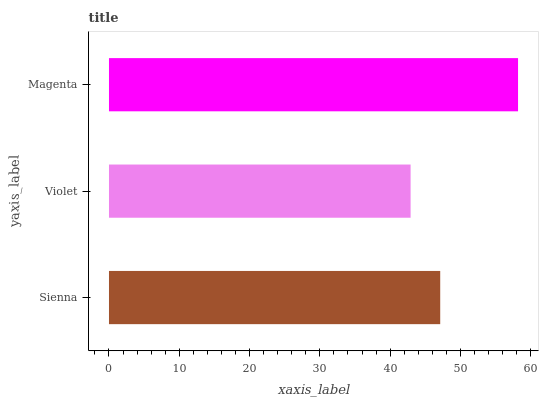Is Violet the minimum?
Answer yes or no. Yes. Is Magenta the maximum?
Answer yes or no. Yes. Is Magenta the minimum?
Answer yes or no. No. Is Violet the maximum?
Answer yes or no. No. Is Magenta greater than Violet?
Answer yes or no. Yes. Is Violet less than Magenta?
Answer yes or no. Yes. Is Violet greater than Magenta?
Answer yes or no. No. Is Magenta less than Violet?
Answer yes or no. No. Is Sienna the high median?
Answer yes or no. Yes. Is Sienna the low median?
Answer yes or no. Yes. Is Violet the high median?
Answer yes or no. No. Is Violet the low median?
Answer yes or no. No. 